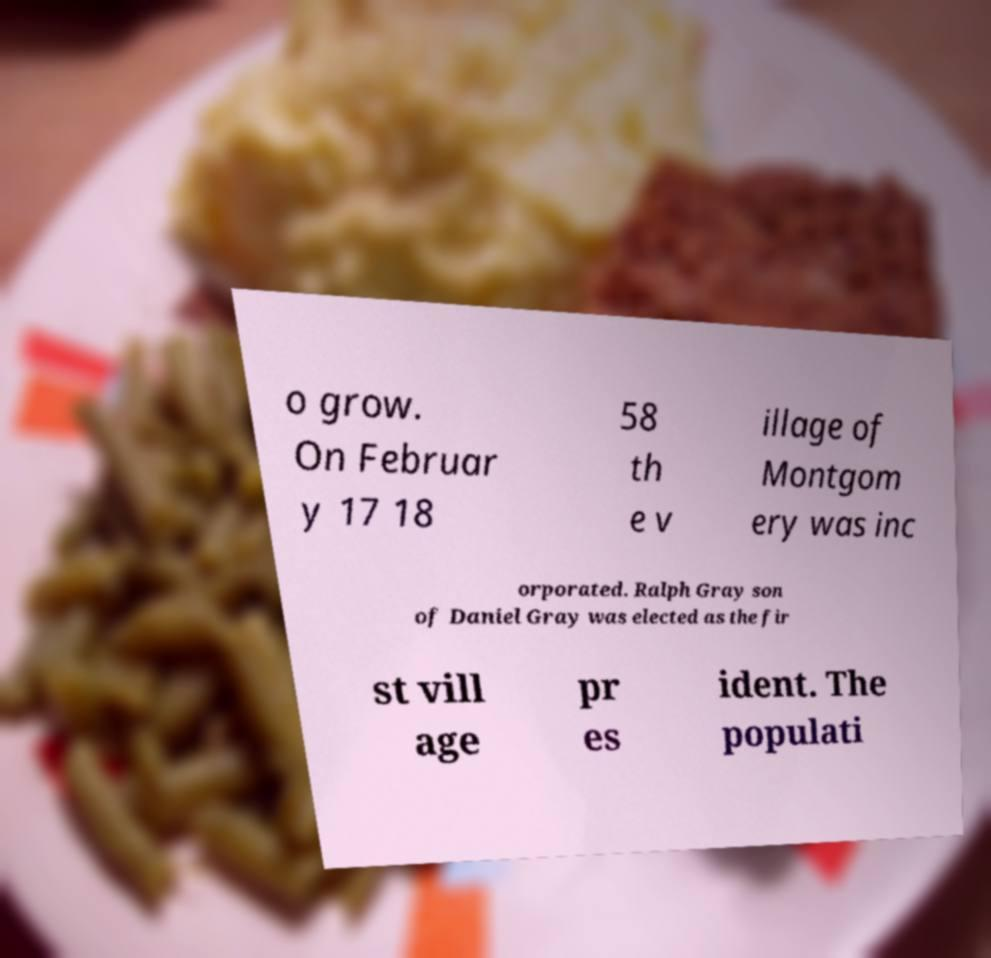Can you read and provide the text displayed in the image?This photo seems to have some interesting text. Can you extract and type it out for me? o grow. On Februar y 17 18 58 th e v illage of Montgom ery was inc orporated. Ralph Gray son of Daniel Gray was elected as the fir st vill age pr es ident. The populati 